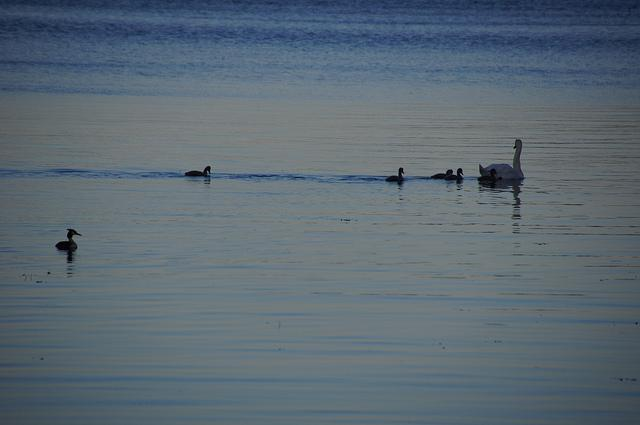What type of birds are the little ones? ducklings 